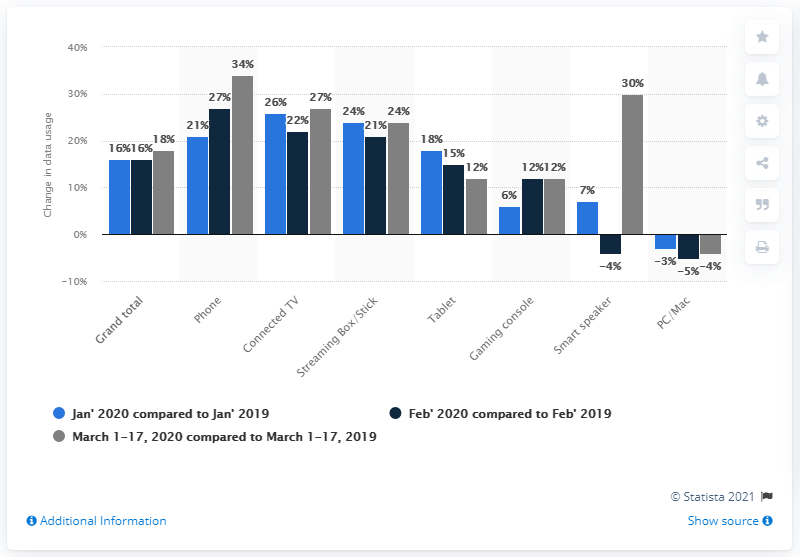List a handful of essential elements in this visual. The average value of the gray bar is 19.13. In March 2020, the in-home data usage of smartphones increased by 34%. The color bar with the highest value is gray. 